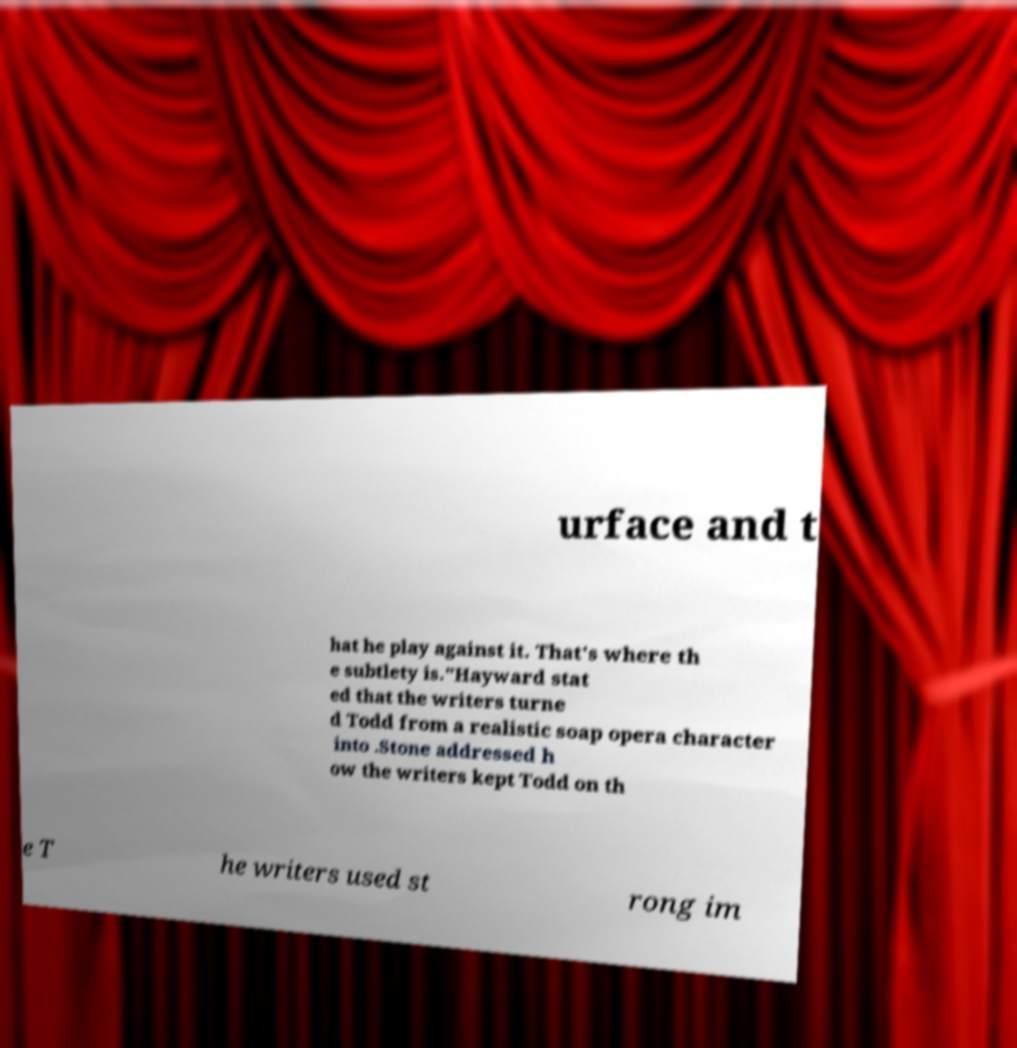For documentation purposes, I need the text within this image transcribed. Could you provide that? urface and t hat he play against it. That's where th e subtlety is."Hayward stat ed that the writers turne d Todd from a realistic soap opera character into .Stone addressed h ow the writers kept Todd on th e T he writers used st rong im 